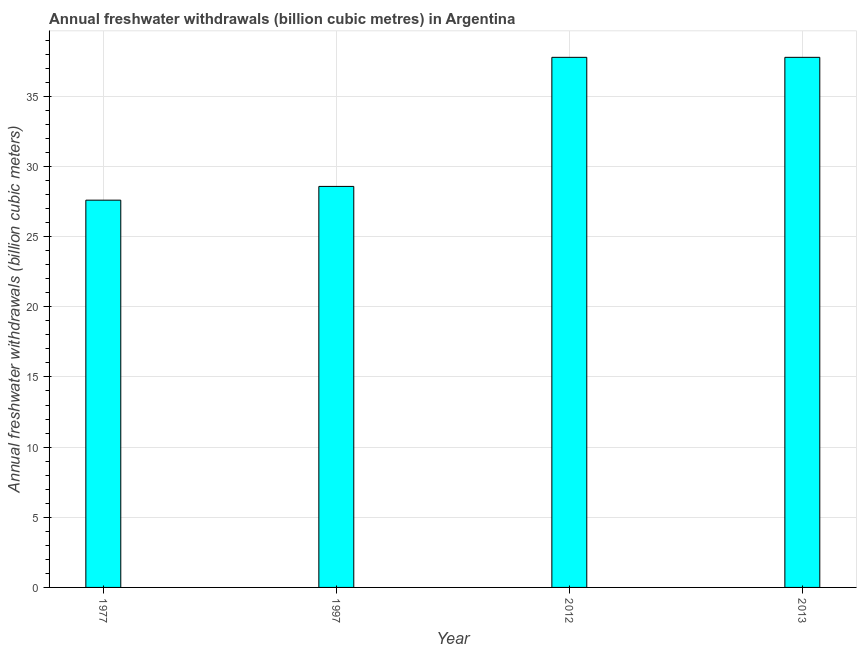Does the graph contain any zero values?
Keep it short and to the point. No. What is the title of the graph?
Provide a succinct answer. Annual freshwater withdrawals (billion cubic metres) in Argentina. What is the label or title of the Y-axis?
Ensure brevity in your answer.  Annual freshwater withdrawals (billion cubic meters). What is the annual freshwater withdrawals in 2013?
Ensure brevity in your answer.  37.78. Across all years, what is the maximum annual freshwater withdrawals?
Keep it short and to the point. 37.78. Across all years, what is the minimum annual freshwater withdrawals?
Keep it short and to the point. 27.6. In which year was the annual freshwater withdrawals maximum?
Your response must be concise. 2012. What is the sum of the annual freshwater withdrawals?
Offer a very short reply. 131.74. What is the average annual freshwater withdrawals per year?
Offer a very short reply. 32.94. What is the median annual freshwater withdrawals?
Provide a succinct answer. 33.18. In how many years, is the annual freshwater withdrawals greater than 6 billion cubic meters?
Provide a short and direct response. 4. What is the ratio of the annual freshwater withdrawals in 1977 to that in 2013?
Ensure brevity in your answer.  0.73. Is the annual freshwater withdrawals in 1977 less than that in 1997?
Your response must be concise. Yes. Is the sum of the annual freshwater withdrawals in 1997 and 2012 greater than the maximum annual freshwater withdrawals across all years?
Provide a short and direct response. Yes. What is the difference between the highest and the lowest annual freshwater withdrawals?
Keep it short and to the point. 10.18. How many bars are there?
Your response must be concise. 4. Are all the bars in the graph horizontal?
Offer a very short reply. No. What is the Annual freshwater withdrawals (billion cubic meters) in 1977?
Keep it short and to the point. 27.6. What is the Annual freshwater withdrawals (billion cubic meters) of 1997?
Keep it short and to the point. 28.58. What is the Annual freshwater withdrawals (billion cubic meters) in 2012?
Your answer should be very brief. 37.78. What is the Annual freshwater withdrawals (billion cubic meters) of 2013?
Provide a succinct answer. 37.78. What is the difference between the Annual freshwater withdrawals (billion cubic meters) in 1977 and 1997?
Your answer should be very brief. -0.98. What is the difference between the Annual freshwater withdrawals (billion cubic meters) in 1977 and 2012?
Make the answer very short. -10.18. What is the difference between the Annual freshwater withdrawals (billion cubic meters) in 1977 and 2013?
Your response must be concise. -10.18. What is the difference between the Annual freshwater withdrawals (billion cubic meters) in 1997 and 2013?
Keep it short and to the point. -9.2. What is the difference between the Annual freshwater withdrawals (billion cubic meters) in 2012 and 2013?
Make the answer very short. 0. What is the ratio of the Annual freshwater withdrawals (billion cubic meters) in 1977 to that in 2012?
Keep it short and to the point. 0.73. What is the ratio of the Annual freshwater withdrawals (billion cubic meters) in 1977 to that in 2013?
Make the answer very short. 0.73. What is the ratio of the Annual freshwater withdrawals (billion cubic meters) in 1997 to that in 2012?
Offer a terse response. 0.76. What is the ratio of the Annual freshwater withdrawals (billion cubic meters) in 1997 to that in 2013?
Your answer should be very brief. 0.76. What is the ratio of the Annual freshwater withdrawals (billion cubic meters) in 2012 to that in 2013?
Provide a short and direct response. 1. 